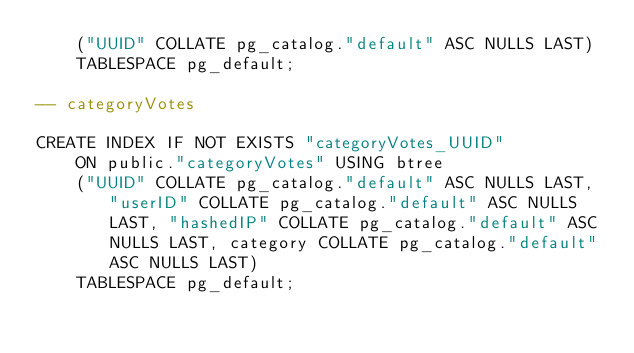<code> <loc_0><loc_0><loc_500><loc_500><_SQL_>    ("UUID" COLLATE pg_catalog."default" ASC NULLS LAST)
    TABLESPACE pg_default;

-- categoryVotes

CREATE INDEX IF NOT EXISTS "categoryVotes_UUID"
    ON public."categoryVotes" USING btree
    ("UUID" COLLATE pg_catalog."default" ASC NULLS LAST, "userID" COLLATE pg_catalog."default" ASC NULLS LAST, "hashedIP" COLLATE pg_catalog."default" ASC NULLS LAST, category COLLATE pg_catalog."default" ASC NULLS LAST)
    TABLESPACE pg_default;</code> 